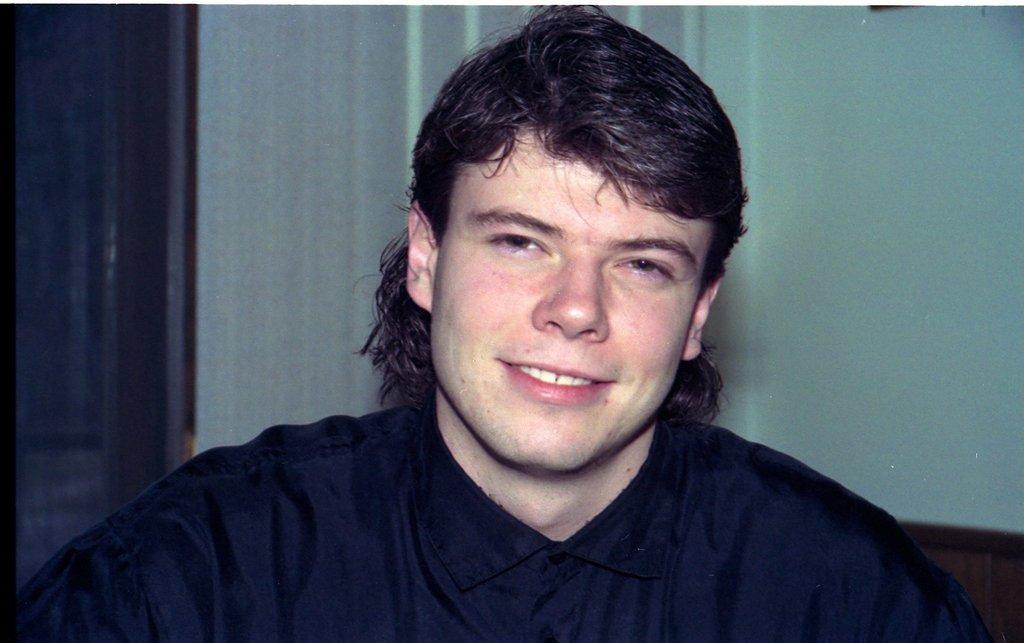Can you describe this image briefly? In this image there is a man in the middle. In the background there is a wall. On the right side it looks like a door. 